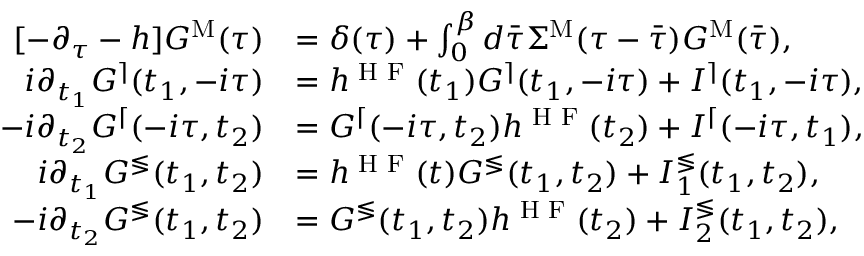<formula> <loc_0><loc_0><loc_500><loc_500>\begin{array} { r l } { [ - \partial _ { \tau } - h ] G ^ { M } ( \tau ) } & { = \delta ( \tau ) + \int _ { 0 } ^ { \beta } d \ B a r { \tau } \Sigma ^ { M } ( \tau - \ B a r { \tau } ) G ^ { M } ( \bar { \tau } ) , } \\ { i \partial _ { t _ { 1 } } G ^ { \rceil } ( t _ { 1 } , - i \tau ) } & { = h ^ { H F } ( t _ { 1 } ) G ^ { \rceil } ( t _ { 1 } , - i \tau ) + I ^ { \rceil } ( t _ { 1 } , - i \tau ) , } \\ { - i \partial _ { t _ { 2 } } G ^ { \lceil } ( - i \tau , t _ { 2 } ) } & { = G ^ { \lceil } ( - i \tau , t _ { 2 } ) h ^ { H F } ( t _ { 2 } ) + I ^ { \lceil } ( - i \tau , t _ { 1 } ) , } \\ { i \partial _ { t _ { 1 } } G ^ { \leq s s g t r } ( t _ { 1 } , t _ { 2 } ) } & { = h ^ { H F } ( t ) G ^ { \leq s s g t r } ( t _ { 1 } , t _ { 2 } ) + I _ { 1 } ^ { \leq s s g t r } ( t _ { 1 } , t _ { 2 } ) , } \\ { - i \partial _ { t _ { 2 } } G ^ { \leq s s g t r } ( t _ { 1 } , t _ { 2 } ) } & { = G ^ { \leq s s g t r } ( t _ { 1 } , t _ { 2 } ) h ^ { H F } ( t _ { 2 } ) + I _ { 2 } ^ { \leq s s g t r } ( t _ { 1 } , t _ { 2 } ) , } \end{array}</formula> 